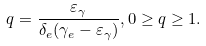Convert formula to latex. <formula><loc_0><loc_0><loc_500><loc_500>q = \frac { \varepsilon _ { \gamma } } { \delta _ { e } ( \gamma _ { e } - \varepsilon _ { \gamma } ) } , 0 \geq q \geq 1 .</formula> 